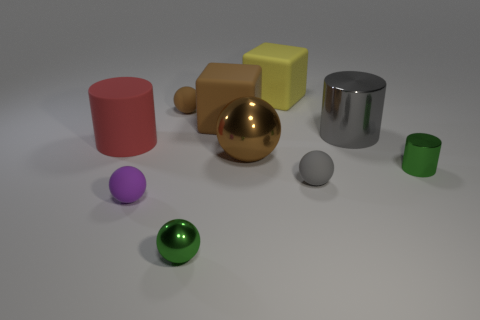Subtract all big brown balls. How many balls are left? 4 Subtract all brown balls. How many balls are left? 3 Subtract all blocks. How many objects are left? 8 Subtract all purple blocks. How many green spheres are left? 1 Subtract all tiny objects. Subtract all gray objects. How many objects are left? 3 Add 8 matte cubes. How many matte cubes are left? 10 Add 6 gray metal things. How many gray metal things exist? 7 Subtract 1 red cylinders. How many objects are left? 9 Subtract 1 cylinders. How many cylinders are left? 2 Subtract all red cylinders. Subtract all brown blocks. How many cylinders are left? 2 